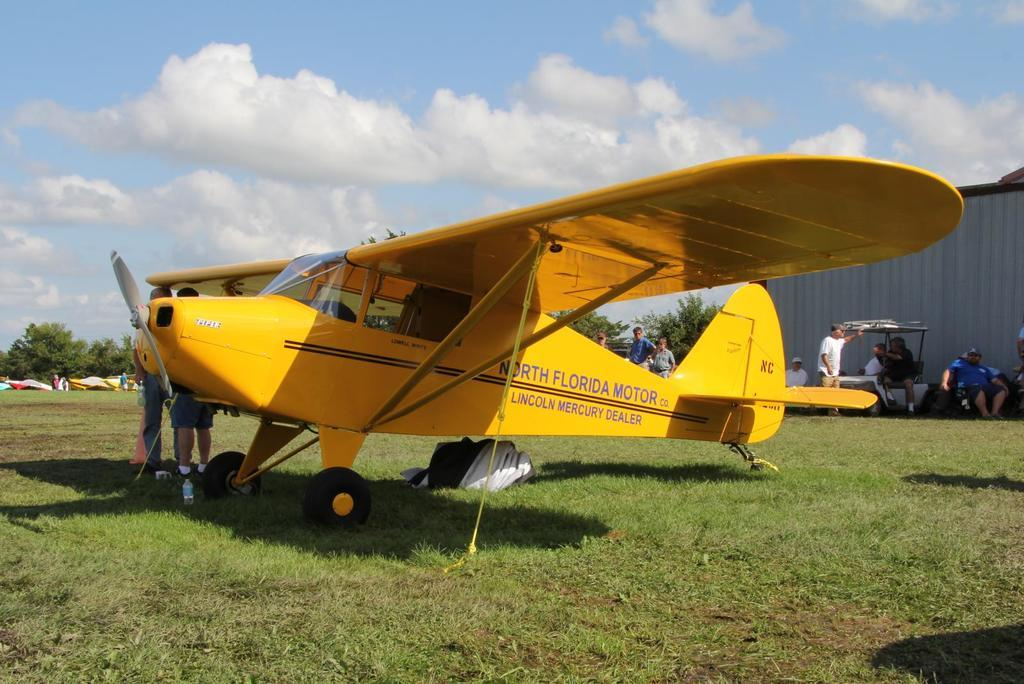Provide a one-sentence caption for the provided image. A yellow airplane from North Florida motor co is parked int he grass. 